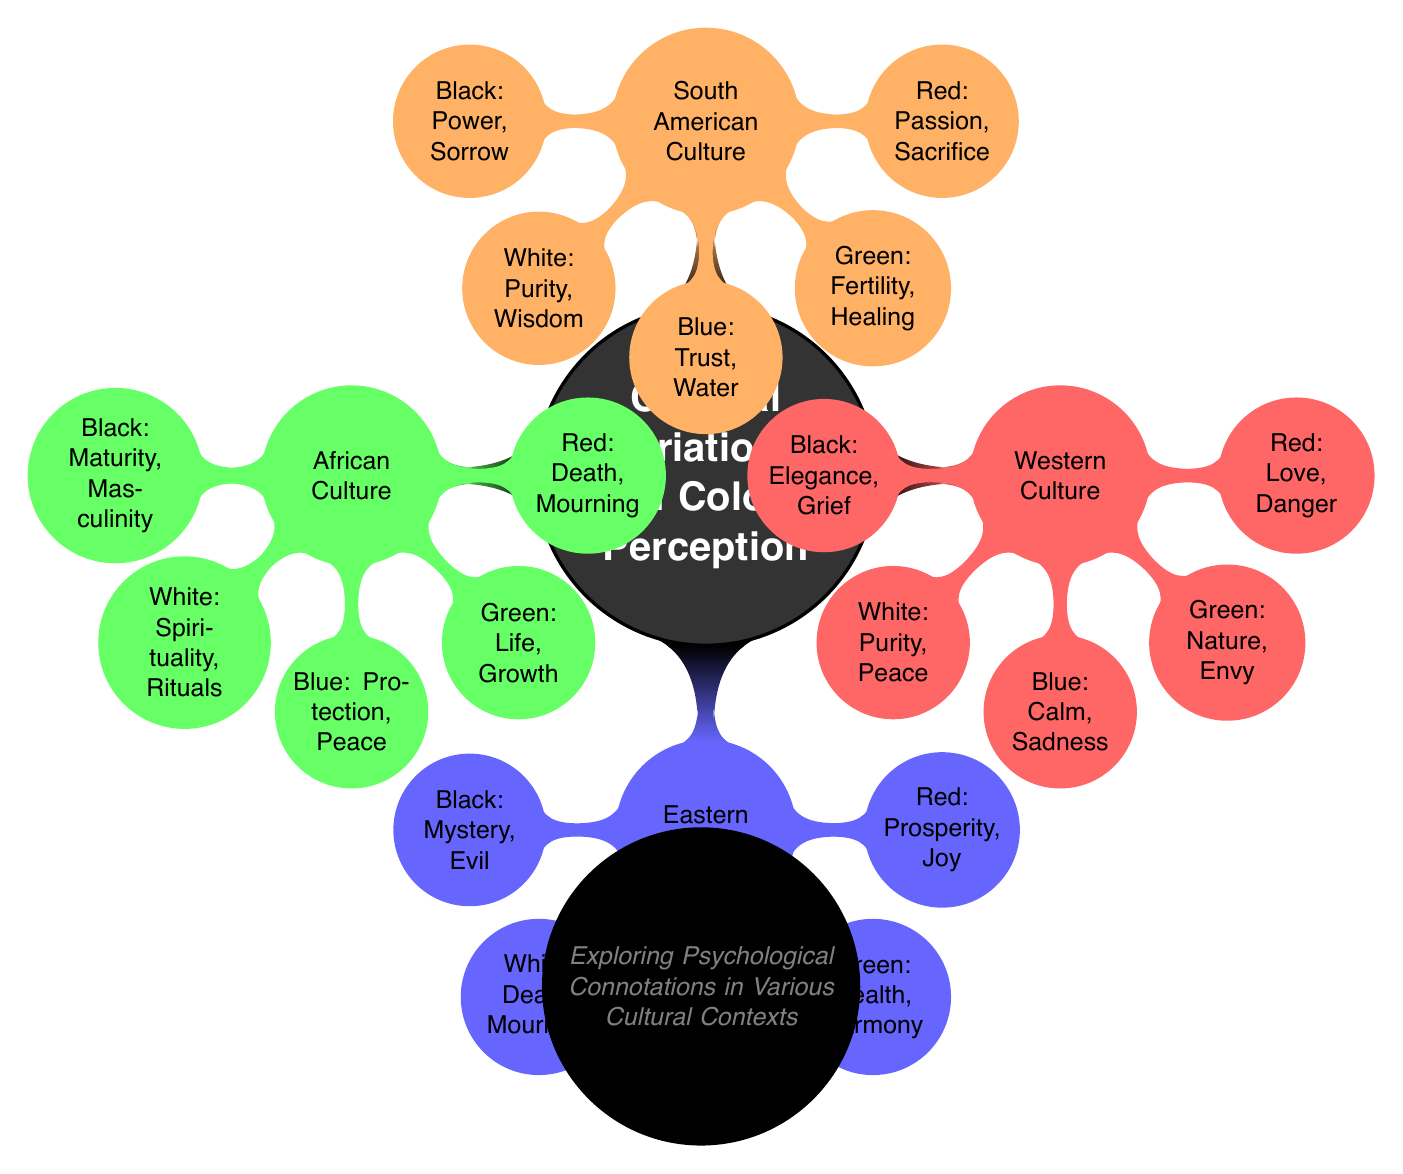What color represents purity in Western Culture? According to the diagram, purity in Western Culture is represented by the color white. This can be found in the Western Culture section and is specifically listed as one of the connotations of color.
Answer: White What psychological connotation is associated with red in Eastern Culture? The diagram states that in Eastern Culture, red is associated with prosperity and joy. This is directly mentioned under the Eastern Culture node in the diagram.
Answer: Prosperity, Joy How many cultures are explored in this diagram? By counting the main cultural nodes in the diagram, it can be observed that there are four cultures: Western, Eastern, African, and South American. Therefore, the total number of cultures explored is four.
Answer: Four What color signifies death in African Culture? In the African Culture section of the diagram, the color red is indicated as signifying death and mourning. This specific information is clearly laid out in the node for African Culture.
Answer: Red Which color in South American Culture symbolizes trust? The diagram indicates that in South American Culture, the color blue is the one that symbolizes trust. This information can be found in the South American Culture section of the diagram.
Answer: Blue Compare the meanings of black in Western Culture and Eastern Culture. The diagram shows that in Western Culture, black is associated with elegance and grief, whereas, in Eastern Culture, black represents mystery and evil. This comparison requires reviewing the meanings associated with black in both cultural contexts.
Answer: Elegance, Grief; Mystery, Evil What color is associated with harmony in Eastern Culture? According to the information in the Eastern Culture section of the diagram, green is the color associated with harmony. This is specifically noted as one of the psychological connotations of the color.
Answer: Green What color in African Culture represents life? In the African Culture section, green is the color that represents life and growth, which is explicitly stated in the diagram.
Answer: Green What is the main theme of the diagram? The primary theme of the diagram, as indicated by the central node, is the exploration of cultural variations in color perception and the psychological connotations attached to colors. This theme encapsulates the entire content of the diagram.
Answer: Cultural Variations in Color Perception 